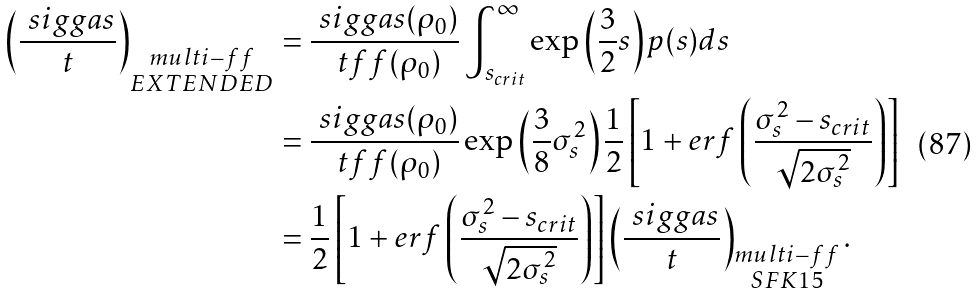<formula> <loc_0><loc_0><loc_500><loc_500>\left ( \frac { \ s i g g a s } { t } \right ) _ { \substack { m u l t i - f f \\ E X T E N D E D } } & = \frac { \ s i g g a s ( \rho _ { 0 } ) } { \ t f f ( \rho _ { 0 } ) } \int _ { s _ { c r i t } } ^ { \infty } \exp \left ( \frac { 3 } { 2 } s \right ) p ( s ) d s \\ & = \frac { \ s i g g a s ( \rho _ { 0 } ) } { \ t f f ( \rho _ { 0 } ) } \exp \left ( \frac { 3 } { 8 } \sigma _ { s } ^ { 2 } \right ) \frac { 1 } { 2 } \left [ 1 + e r f \left ( \frac { \sigma _ { s } ^ { 2 } - s _ { c r i t } } { \sqrt { 2 \sigma _ { s } ^ { 2 } } } \right ) \right ] \\ & = \frac { 1 } { 2 } \left [ 1 + e r f \left ( \frac { \sigma _ { s } ^ { 2 } - s _ { c r i t } } { \sqrt { 2 \sigma _ { s } ^ { 2 } } } \right ) \right ] \left ( \frac { \ s i g g a s } { t } \right ) _ { \substack { m u l t i - f f \\ S F K 1 5 } } .</formula> 